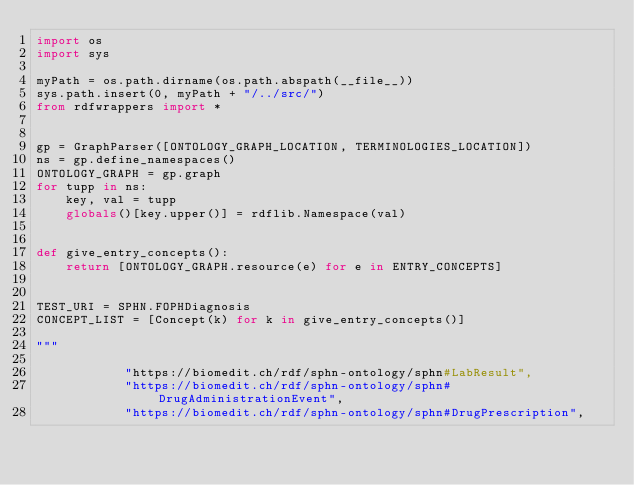<code> <loc_0><loc_0><loc_500><loc_500><_Python_>import os
import sys

myPath = os.path.dirname(os.path.abspath(__file__))
sys.path.insert(0, myPath + "/../src/")
from rdfwrappers import *


gp = GraphParser([ONTOLOGY_GRAPH_LOCATION, TERMINOLOGIES_LOCATION])
ns = gp.define_namespaces()
ONTOLOGY_GRAPH = gp.graph
for tupp in ns:
    key, val = tupp
    globals()[key.upper()] = rdflib.Namespace(val)


def give_entry_concepts():
    return [ONTOLOGY_GRAPH.resource(e) for e in ENTRY_CONCEPTS]


TEST_URI = SPHN.FOPHDiagnosis
CONCEPT_LIST = [Concept(k) for k in give_entry_concepts()]

"""

            "https://biomedit.ch/rdf/sphn-ontology/sphn#LabResult",
            "https://biomedit.ch/rdf/sphn-ontology/sphn#DrugAdministrationEvent",
            "https://biomedit.ch/rdf/sphn-ontology/sphn#DrugPrescription",</code> 